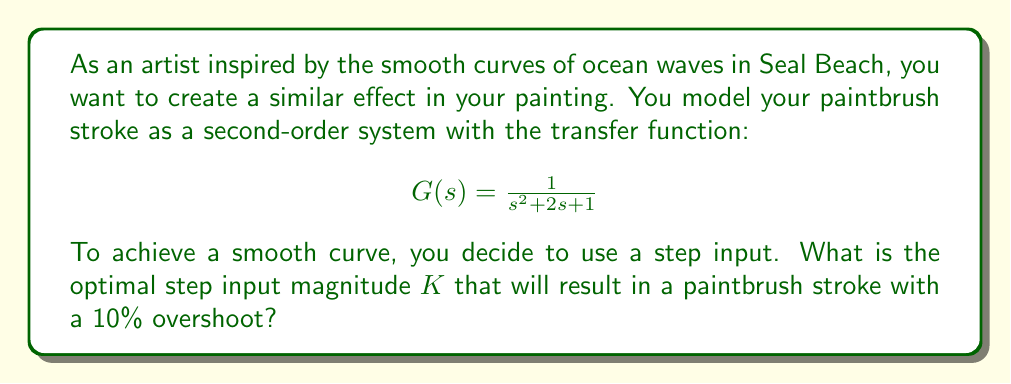Can you solve this math problem? To solve this problem, we'll follow these steps:

1) For a second-order system, the percent overshoot (PO) is related to the damping ratio $\zeta$ by the equation:

   $$PO = 100e^{-\frac{\zeta\pi}{\sqrt{1-\zeta^2}}}$$

2) Given a 10% overshoot, we can solve for $\zeta$:

   $$0.10 = e^{-\frac{\zeta\pi}{\sqrt{1-\zeta^2}}}$$

   Taking the natural log of both sides:

   $$\ln(0.10) = -\frac{\zeta\pi}{\sqrt{1-\zeta^2}}$$

   Solving numerically, we get $\zeta \approx 0.5912$

3) For the given transfer function $G(s) = \frac{1}{s^2 + 2s + 1}$, we can identify that the natural frequency $\omega_n = 1$ and the damping ratio $\zeta = 1$.

4) To achieve the desired damping ratio of 0.5912, we need to scale the input. The scaling factor $K$ will modify the transfer function to:

   $$G'(s) = \frac{K}{s^2 + 2s + 1}$$

5) The new damping ratio will be $\zeta' = \frac{\zeta}{\sqrt{K}} = \frac{1}{\sqrt{K}}$

6) Setting this equal to our desired damping ratio:

   $$\frac{1}{\sqrt{K}} = 0.5912$$

7) Solving for $K$:

   $$K = (\frac{1}{0.5912})^2 \approx 2.8628$$

Therefore, the optimal step input magnitude is approximately 2.8628.
Answer: $K \approx 2.8628$ 